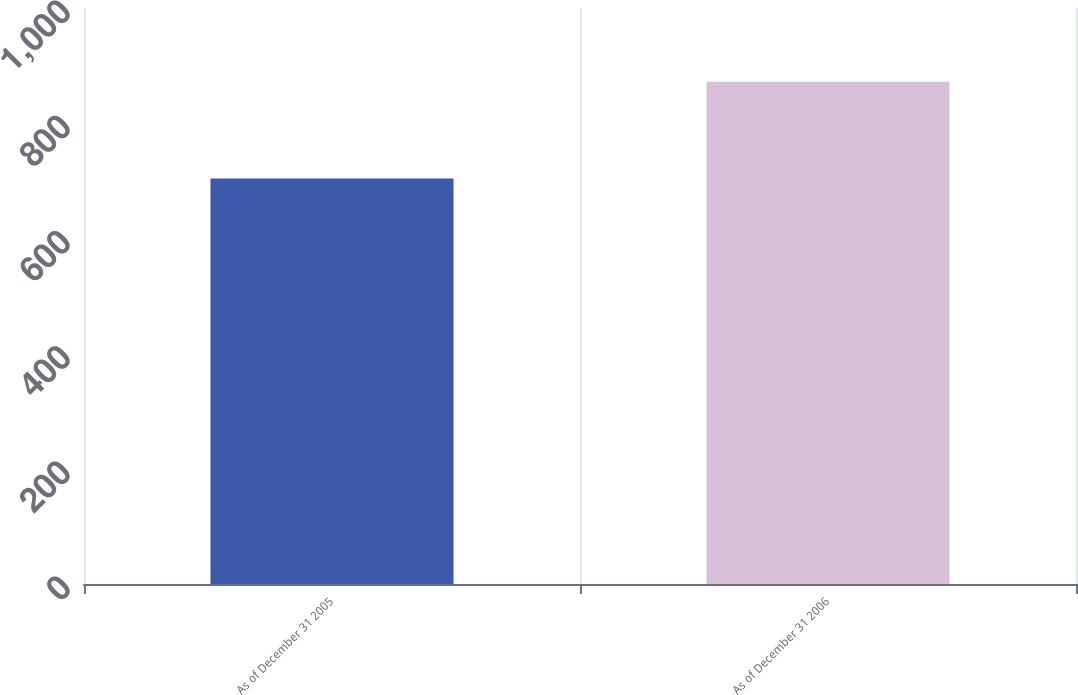Convert chart. <chart><loc_0><loc_0><loc_500><loc_500><bar_chart><fcel>As of December 31 2005<fcel>As of December 31 2006<nl><fcel>704<fcel>872<nl></chart> 